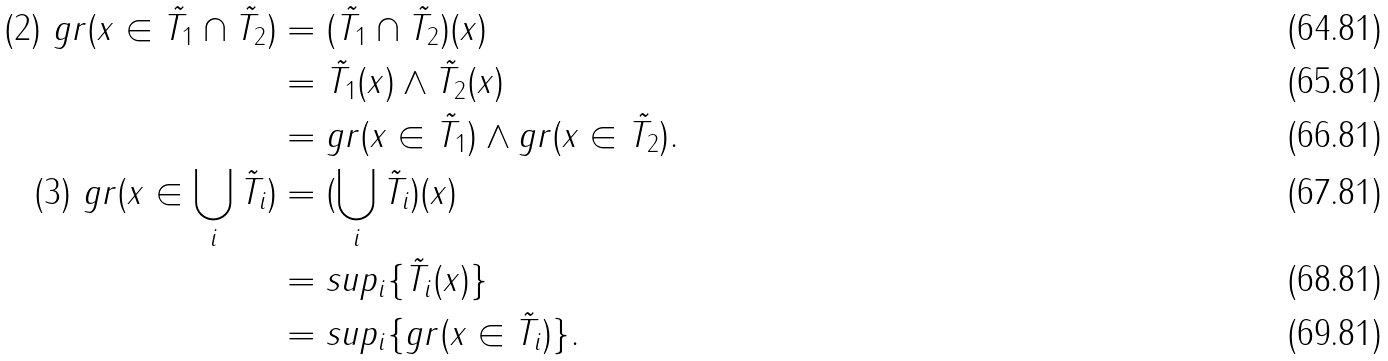Convert formula to latex. <formula><loc_0><loc_0><loc_500><loc_500>( 2 ) \ g r ( x \in \tilde { T _ { 1 } } \cap \tilde { T _ { 2 } } ) & = ( \tilde { T _ { 1 } } \cap \tilde { T _ { 2 } } ) ( x ) \\ & = \tilde { T _ { 1 } } ( x ) \wedge \tilde { T _ { 2 } } ( x ) \\ & = g r ( x \in \tilde { T _ { 1 } } ) \wedge g r ( x \in \tilde { T _ { 2 } } ) . \\ ( 3 ) \ g r ( x \in \bigcup _ { i } \tilde { T _ { i } } ) & = ( \bigcup _ { i } \tilde { T _ { i } } ) ( x ) \\ & = s u p _ { i } \{ \tilde { T _ { i } } ( x ) \} \\ & = s u p _ { i } \{ g r ( x \in \tilde { T _ { i } } ) \} .</formula> 